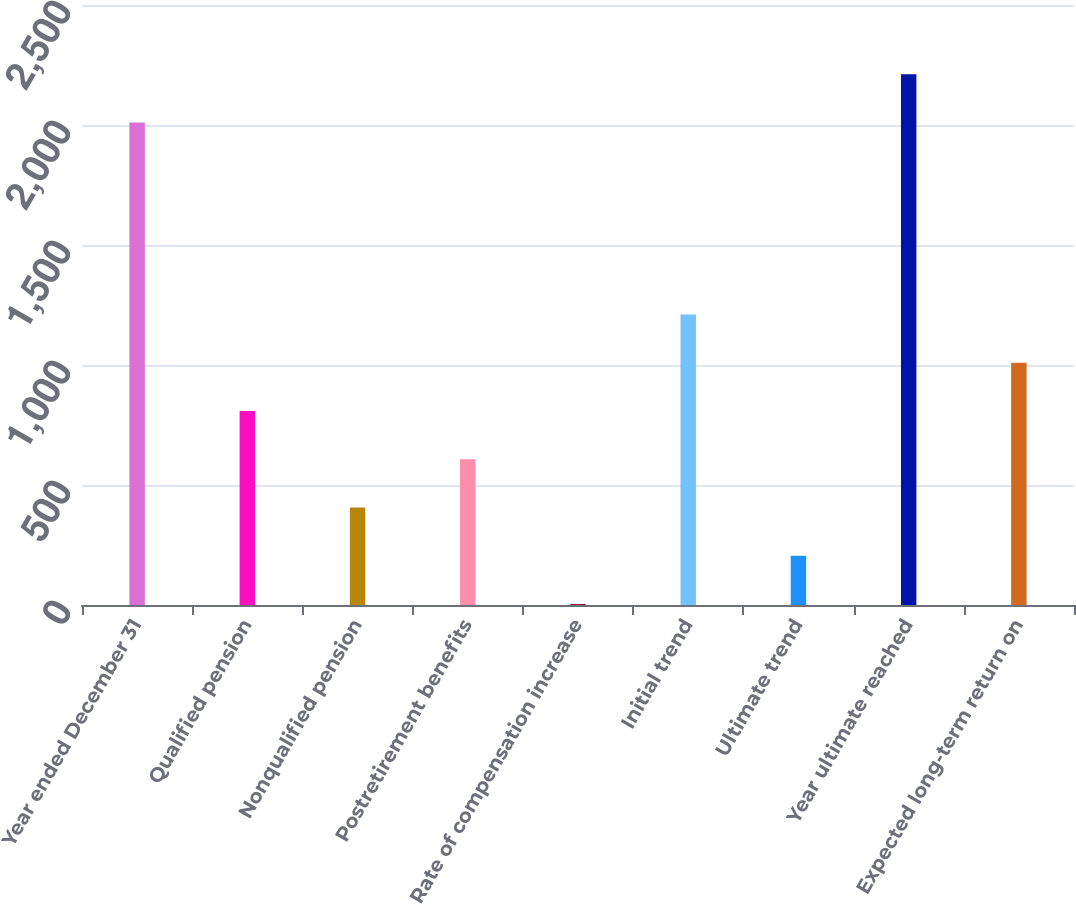Convert chart to OTSL. <chart><loc_0><loc_0><loc_500><loc_500><bar_chart><fcel>Year ended December 31<fcel>Qualified pension<fcel>Nonqualified pension<fcel>Postretirement benefits<fcel>Rate of compensation increase<fcel>Initial trend<fcel>Ultimate trend<fcel>Year ultimate reached<fcel>Expected long-term return on<nl><fcel>2010<fcel>808<fcel>406<fcel>607<fcel>4<fcel>1210<fcel>205<fcel>2211<fcel>1009<nl></chart> 